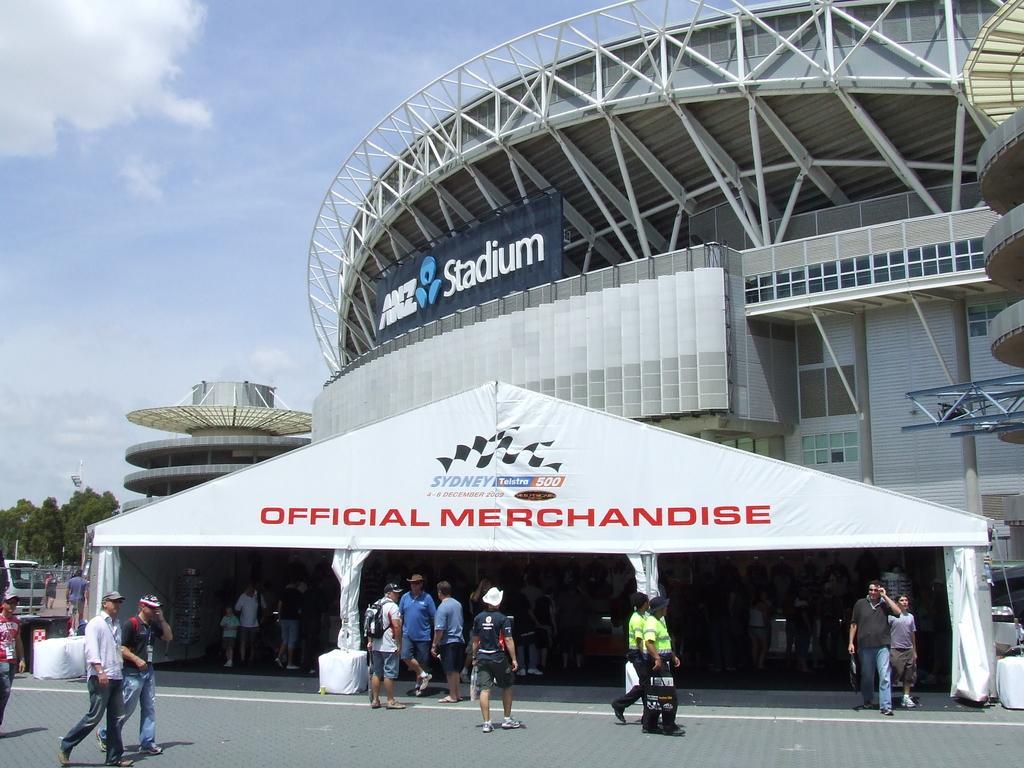Could you give a brief overview of what you see in this image? Here we can see group of people and there is a stadium. Here we can see trees, boards, and poles. In the background there is sky with clouds. 